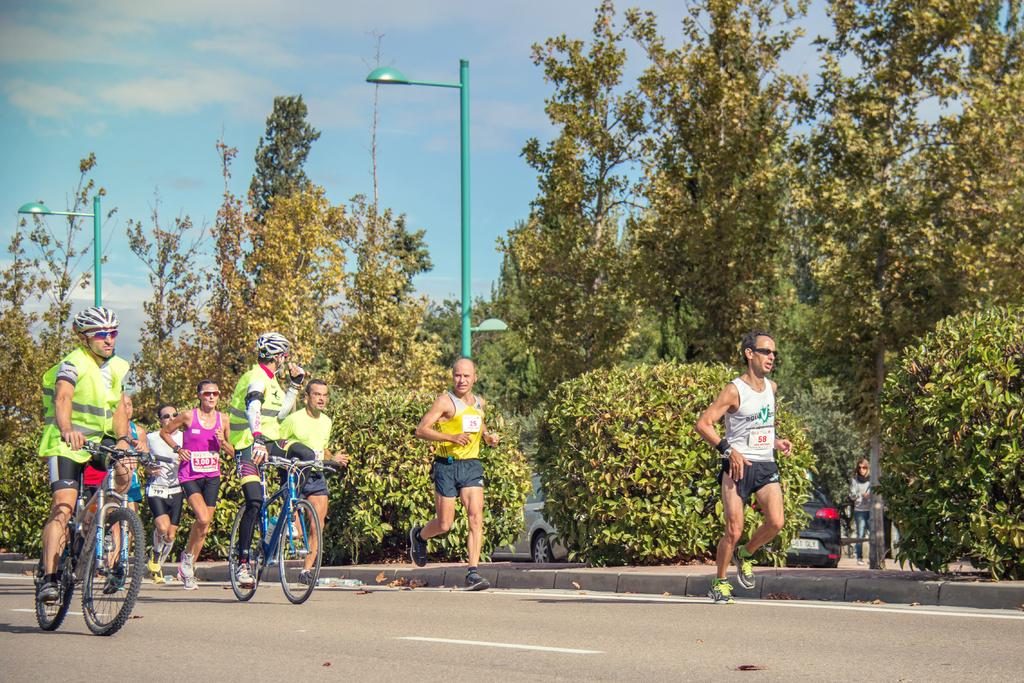What are the two persons in the image doing? The two persons in the image are riding bicycles. What else is happening in the image? There are people running in the image. What type of vegetation can be seen in the image? There are green color trees in the image. What is visible at the top of the image? The sky is visible at the top of the image. Is there a bridge visible in the image? No, there is no bridge present in the image. What is the hope of the people running in the image? The image does not provide information about the hopes or intentions of the people running, so it cannot be determined from the image. 